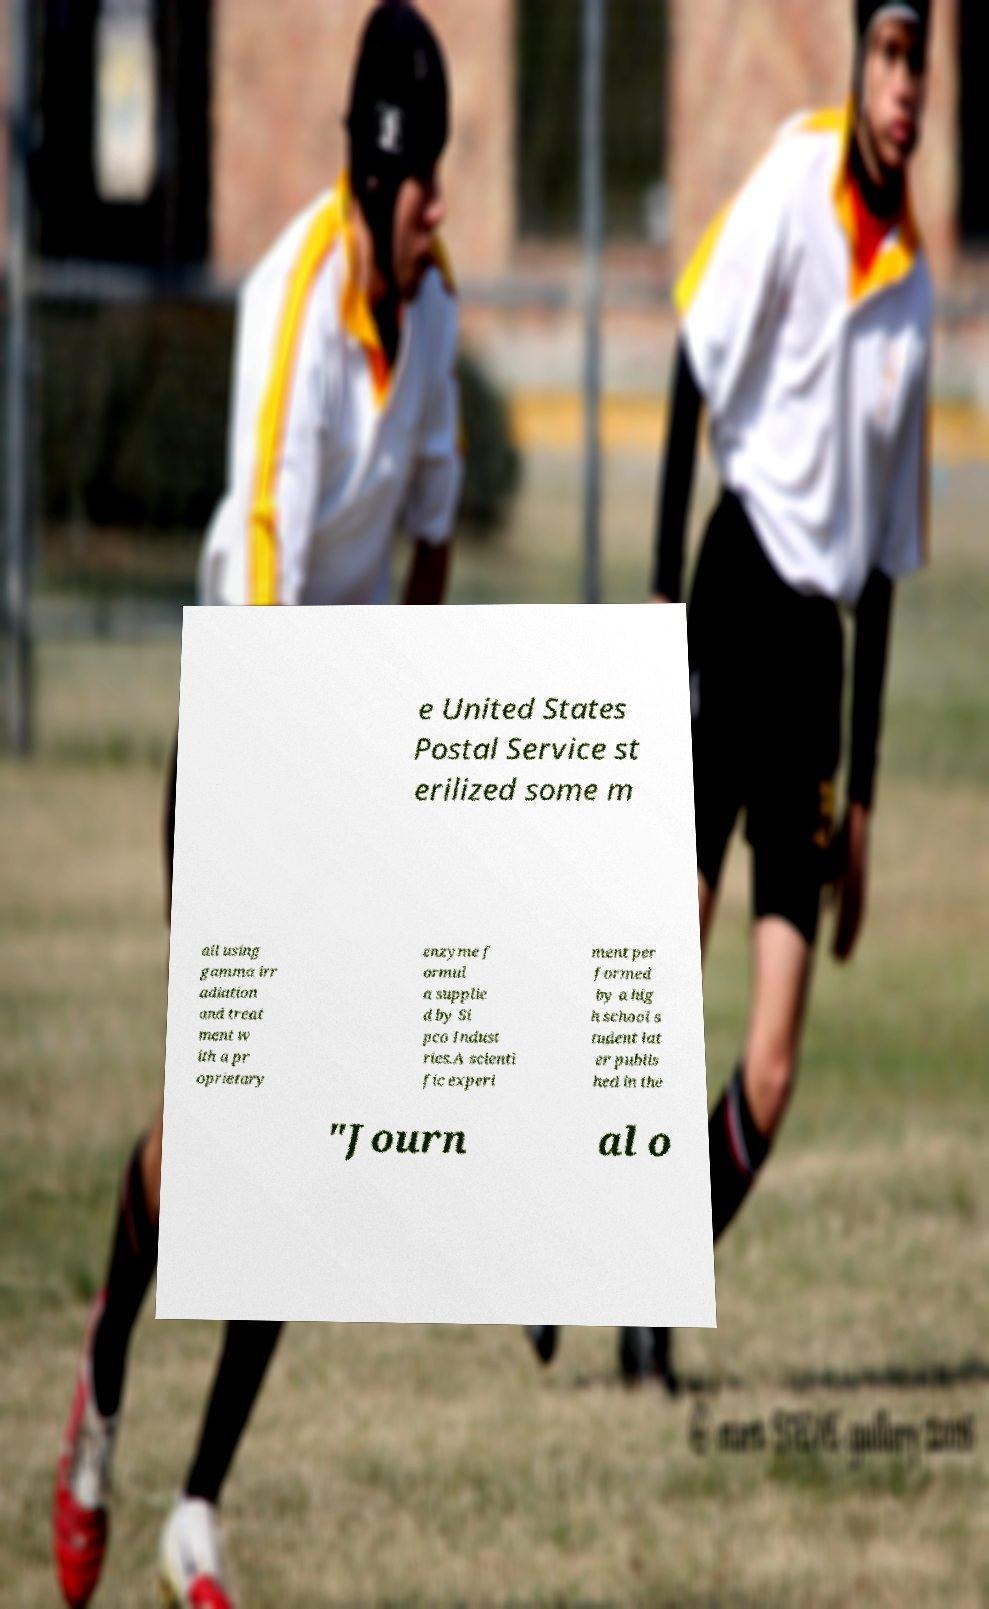Could you extract and type out the text from this image? e United States Postal Service st erilized some m ail using gamma irr adiation and treat ment w ith a pr oprietary enzyme f ormul a supplie d by Si pco Indust ries.A scienti fic experi ment per formed by a hig h school s tudent lat er publis hed in the "Journ al o 